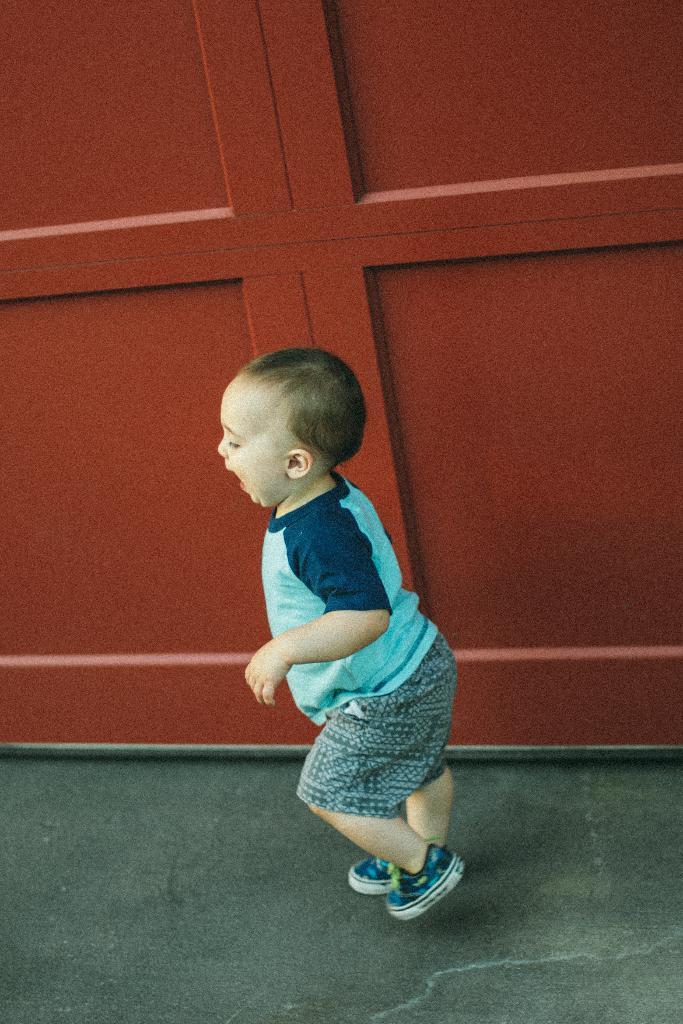Can you describe this image briefly? In the middle of the image we can see a kid on the floor. In the background there is a wooden wall. 